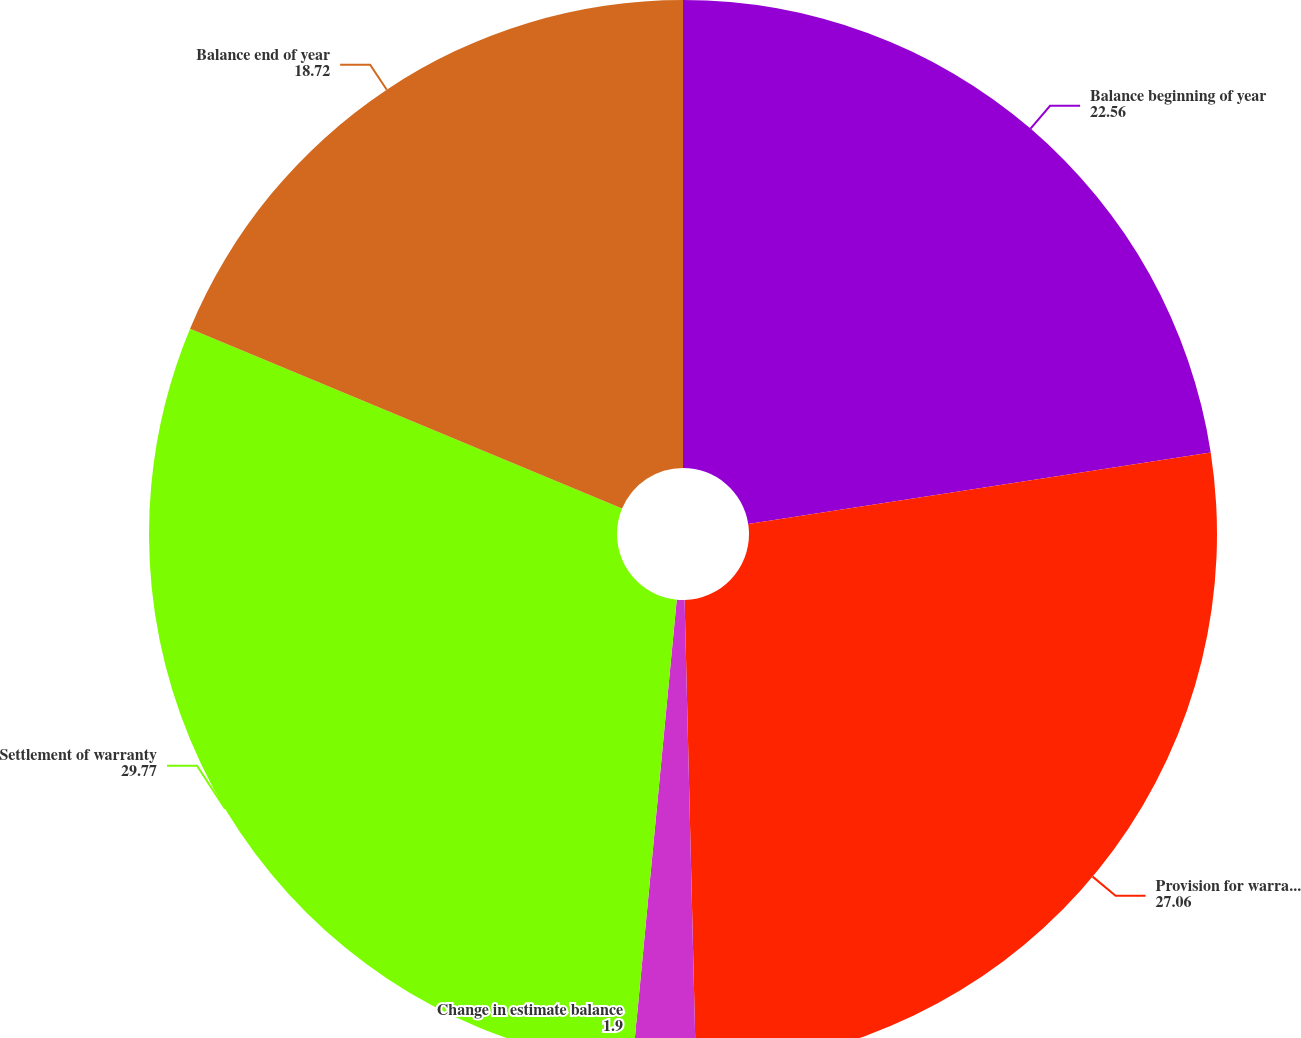Convert chart. <chart><loc_0><loc_0><loc_500><loc_500><pie_chart><fcel>Balance beginning of year<fcel>Provision for warranty expense<fcel>Change in estimate balance<fcel>Settlement of warranty<fcel>Balance end of year<nl><fcel>22.56%<fcel>27.06%<fcel>1.9%<fcel>29.77%<fcel>18.72%<nl></chart> 